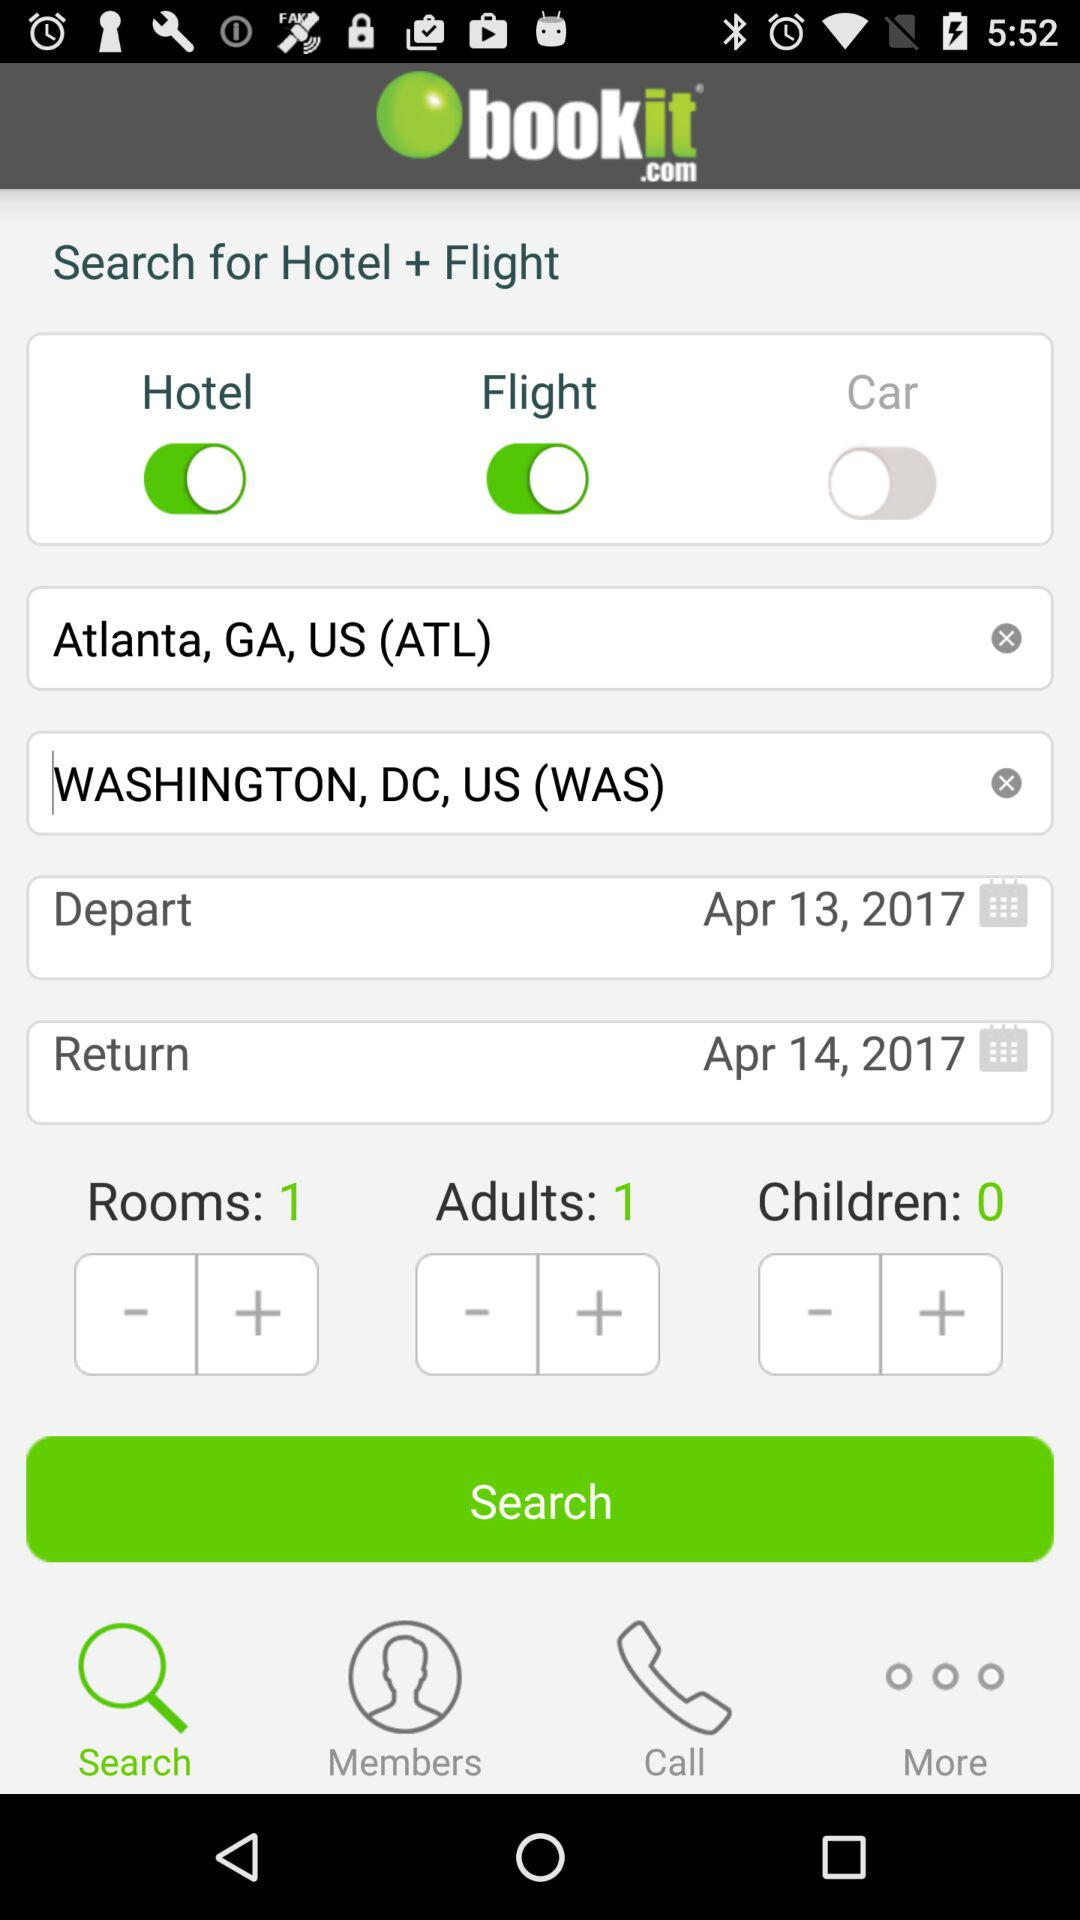What is the return date? The return date is April 14, 2017. 